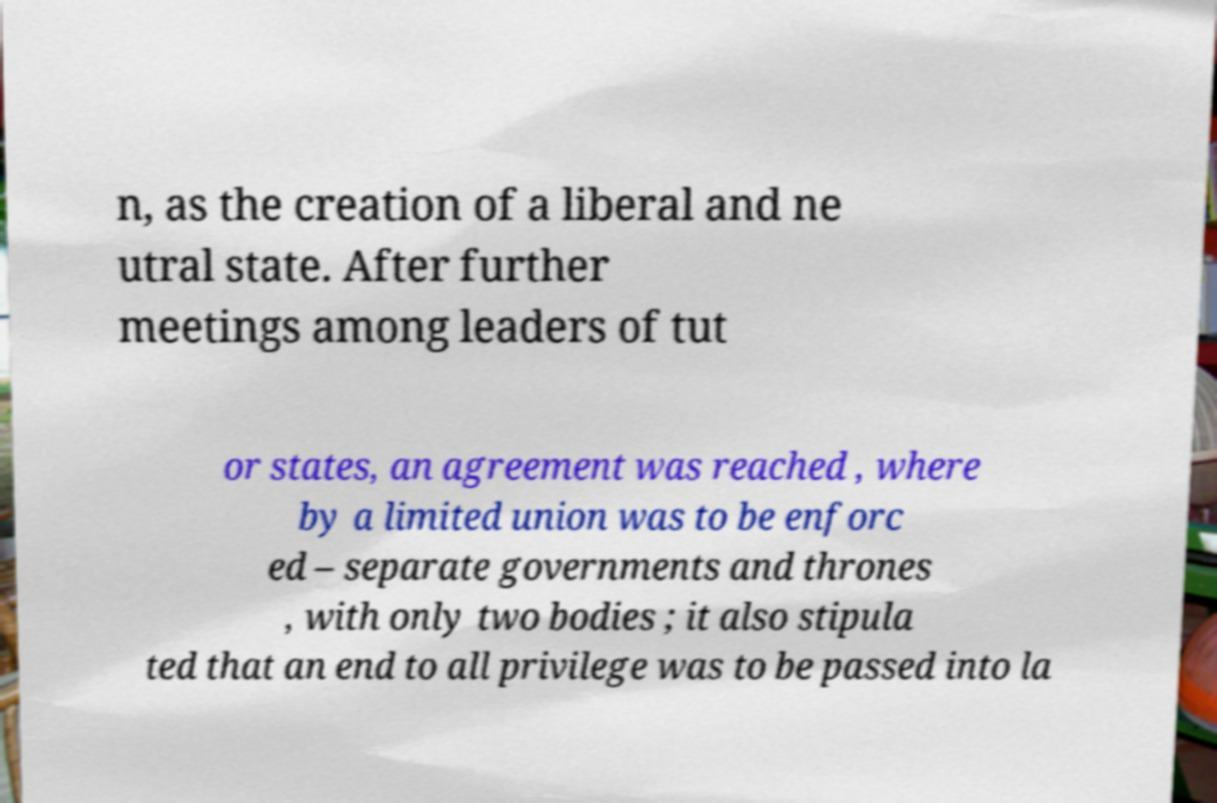What messages or text are displayed in this image? I need them in a readable, typed format. n, as the creation of a liberal and ne utral state. After further meetings among leaders of tut or states, an agreement was reached , where by a limited union was to be enforc ed – separate governments and thrones , with only two bodies ; it also stipula ted that an end to all privilege was to be passed into la 